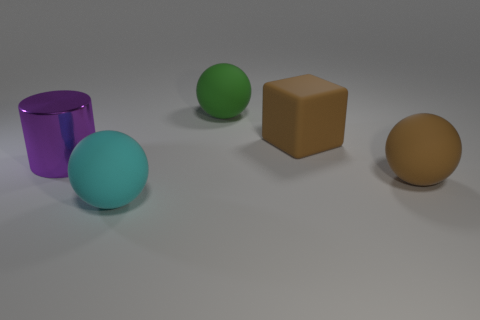How many things are cyan rubber spheres or purple shiny objects?
Offer a very short reply. 2. What number of other large matte things are the same shape as the large green matte thing?
Provide a short and direct response. 2. Is the material of the green sphere the same as the brown thing that is in front of the brown cube?
Make the answer very short. Yes. What is the size of the green thing that is made of the same material as the big cyan object?
Offer a very short reply. Large. There is a brown rubber object behind the big purple cylinder; what size is it?
Offer a terse response. Large. How many matte cubes have the same size as the cyan matte sphere?
Provide a short and direct response. 1. What size is the rubber ball that is the same color as the big block?
Offer a very short reply. Large. Are there any spheres of the same color as the cylinder?
Your answer should be compact. No. There is a rubber cube that is the same size as the purple metallic cylinder; what color is it?
Provide a succinct answer. Brown. There is a big metal cylinder; is its color the same as the big object that is behind the big cube?
Your answer should be compact. No. 